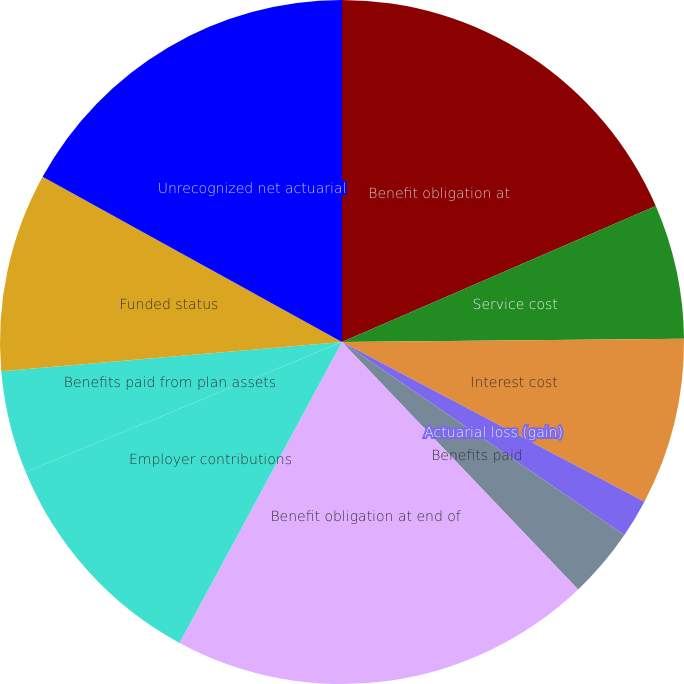<chart> <loc_0><loc_0><loc_500><loc_500><pie_chart><fcel>Benefit obligation at<fcel>Service cost<fcel>Interest cost<fcel>Actuarial loss (gain)<fcel>Benefits paid<fcel>Benefit obligation at end of<fcel>Employer contributions<fcel>Benefits paid from plan assets<fcel>Funded status<fcel>Unrecognized net actuarial<nl><fcel>18.49%<fcel>6.36%<fcel>7.88%<fcel>1.81%<fcel>3.33%<fcel>20.01%<fcel>10.91%<fcel>4.85%<fcel>9.39%<fcel>16.97%<nl></chart> 